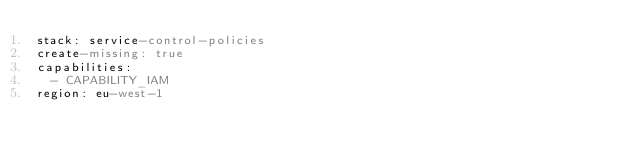<code> <loc_0><loc_0><loc_500><loc_500><_YAML_>stack: service-control-policies
create-missing: true
capabilities:
  - CAPABILITY_IAM
region: eu-west-1
</code> 